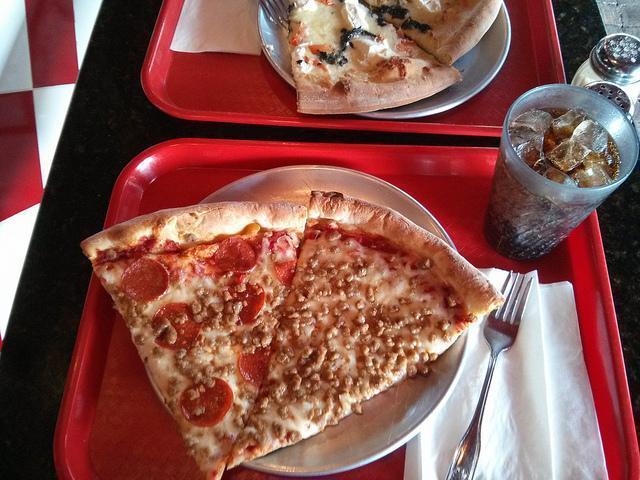How many cups are visible?
Give a very brief answer. 1. How many pizzas are visible?
Give a very brief answer. 3. 